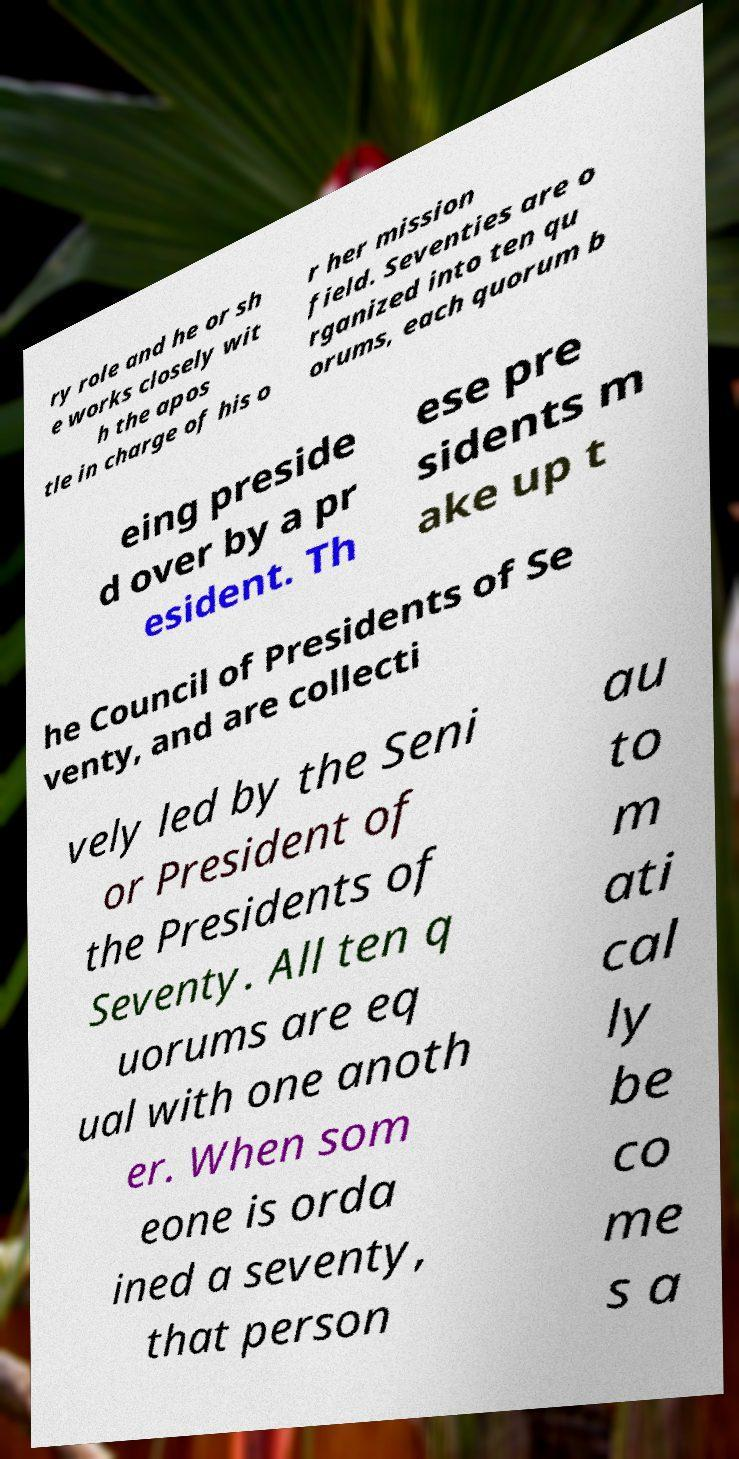For documentation purposes, I need the text within this image transcribed. Could you provide that? ry role and he or sh e works closely wit h the apos tle in charge of his o r her mission field. Seventies are o rganized into ten qu orums, each quorum b eing preside d over by a pr esident. Th ese pre sidents m ake up t he Council of Presidents of Se venty, and are collecti vely led by the Seni or President of the Presidents of Seventy. All ten q uorums are eq ual with one anoth er. When som eone is orda ined a seventy, that person au to m ati cal ly be co me s a 